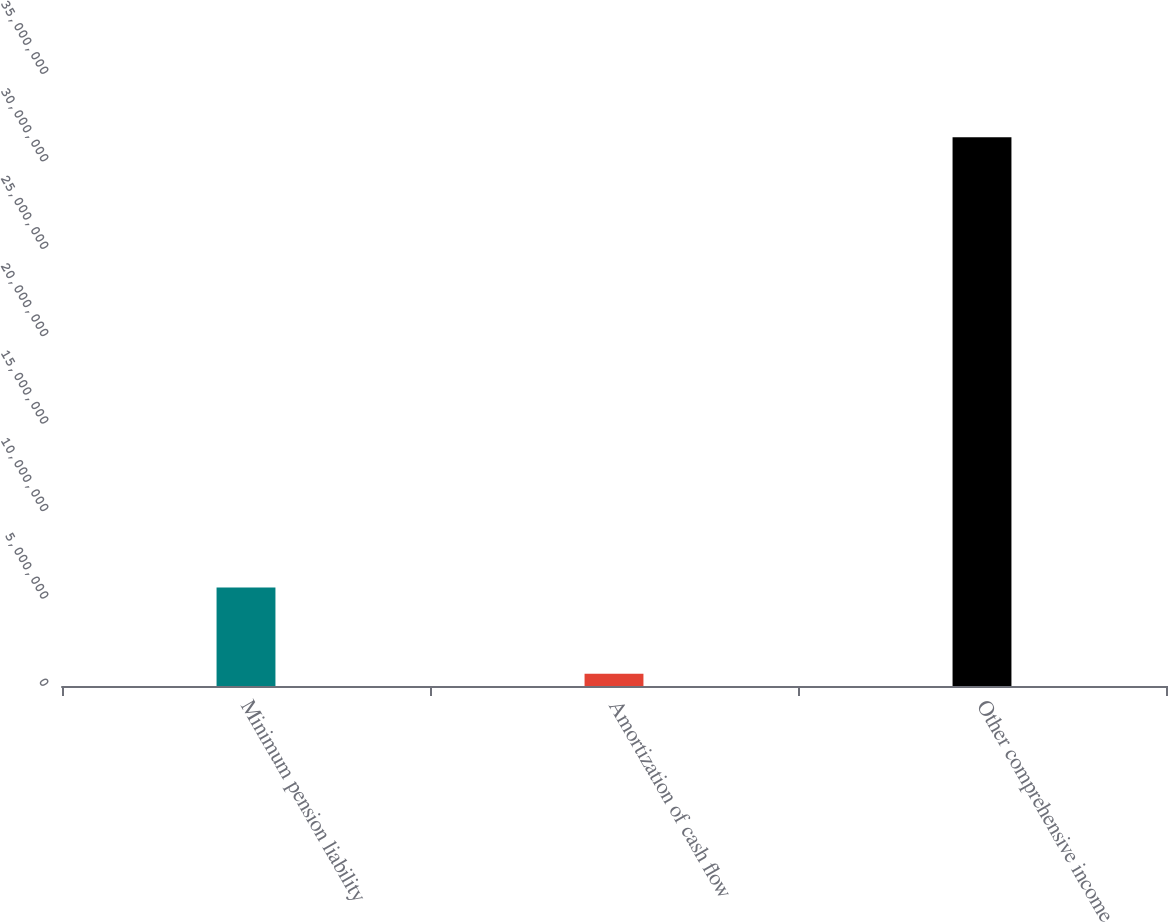Convert chart to OTSL. <chart><loc_0><loc_0><loc_500><loc_500><bar_chart><fcel>Minimum pension liability<fcel>Amortization of cash flow<fcel>Other comprehensive income<nl><fcel>5.633e+06<fcel>694000<fcel>3.1379e+07<nl></chart> 